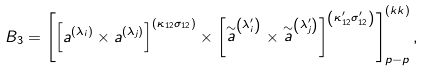<formula> <loc_0><loc_0><loc_500><loc_500>B _ { 3 } = \left [ \left [ a ^ { \left ( \lambda _ { i } \right ) } \times a ^ { \left ( \lambda _ { j } \right ) } \right ] ^ { \left ( \kappa _ { 1 2 } \sigma _ { 1 2 } \right ) } \times \left [ \stackrel { \sim } { a } ^ { \left ( \lambda _ { i } ^ { \prime } \right ) } \times \stackrel { \sim } { a } ^ { \left ( \lambda _ { j } ^ { \prime } \right ) } \right ] ^ { \left ( \kappa _ { 1 2 } ^ { \prime } \sigma _ { 1 2 } ^ { \prime } \right ) } \right ] _ { p - p } ^ { \left ( k k \right ) } ,</formula> 